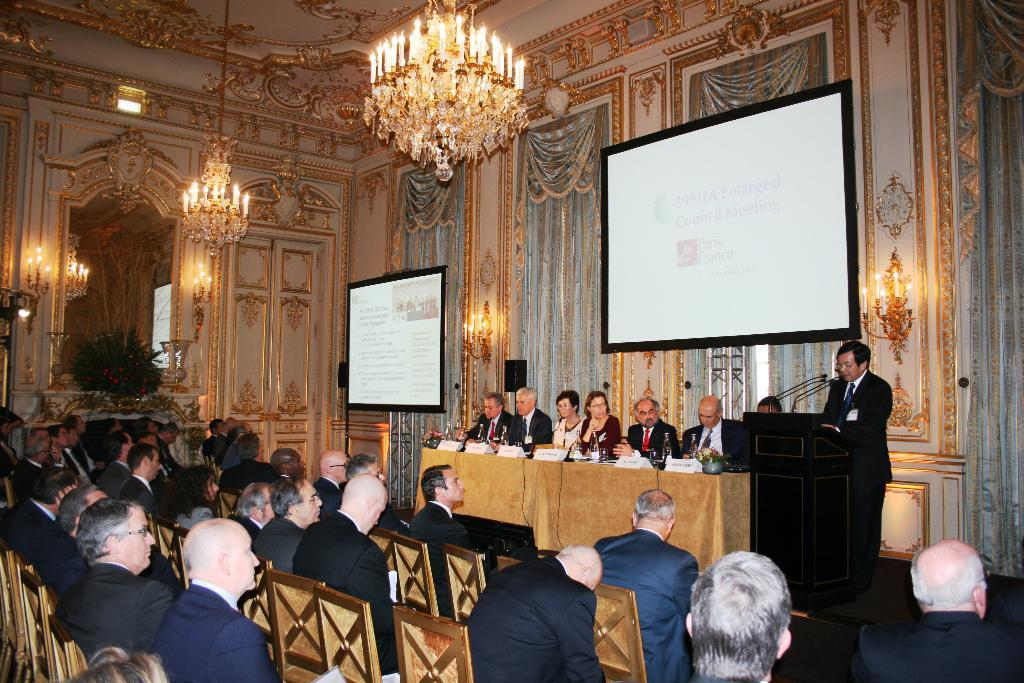What is the man at the podium doing in the image? The man at the podium is speaking. What are the people in the image doing? People are listening to the man. Are there any other individuals on the stage besides the speaker? Yes, there are other people on the stage. What type of fish can be seen swimming in the man's stomach in the image? There is no fish or reference to a stomach in the image; it features a man speaking at a podium with people listening. 